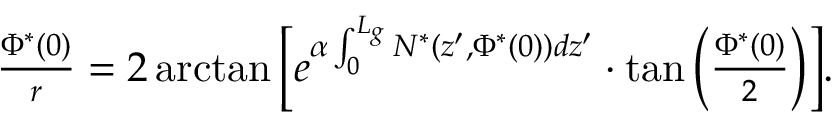Convert formula to latex. <formula><loc_0><loc_0><loc_500><loc_500>\begin{array} { r } { \frac { \Phi ^ { * } ( 0 ) } { r } = 2 \arctan \left [ e ^ { \alpha \int _ { 0 } ^ { L _ { g } } N ^ { * } ( z ^ { \prime } , \Phi ^ { * } ( 0 ) ) d z ^ { \prime } } \cdot \tan \left ( \frac { \Phi ^ { * } ( 0 ) } { 2 } \right ) \right ] . } \end{array}</formula> 